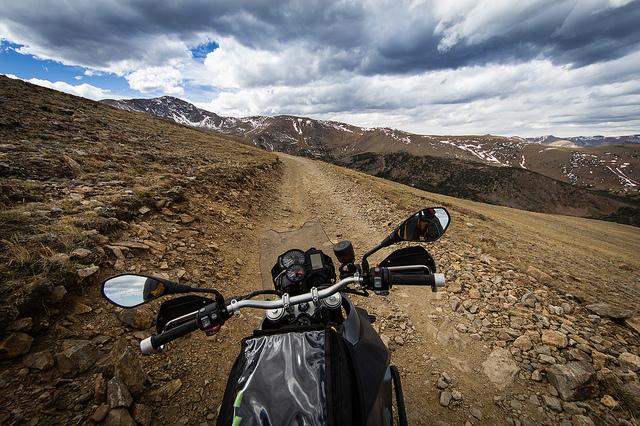Is it cloudy?
Concise answer only. Yes. Is the bike parked in the middle of nowhere?
Give a very brief answer. Yes. Are those mountains in the distance?
Be succinct. Yes. 